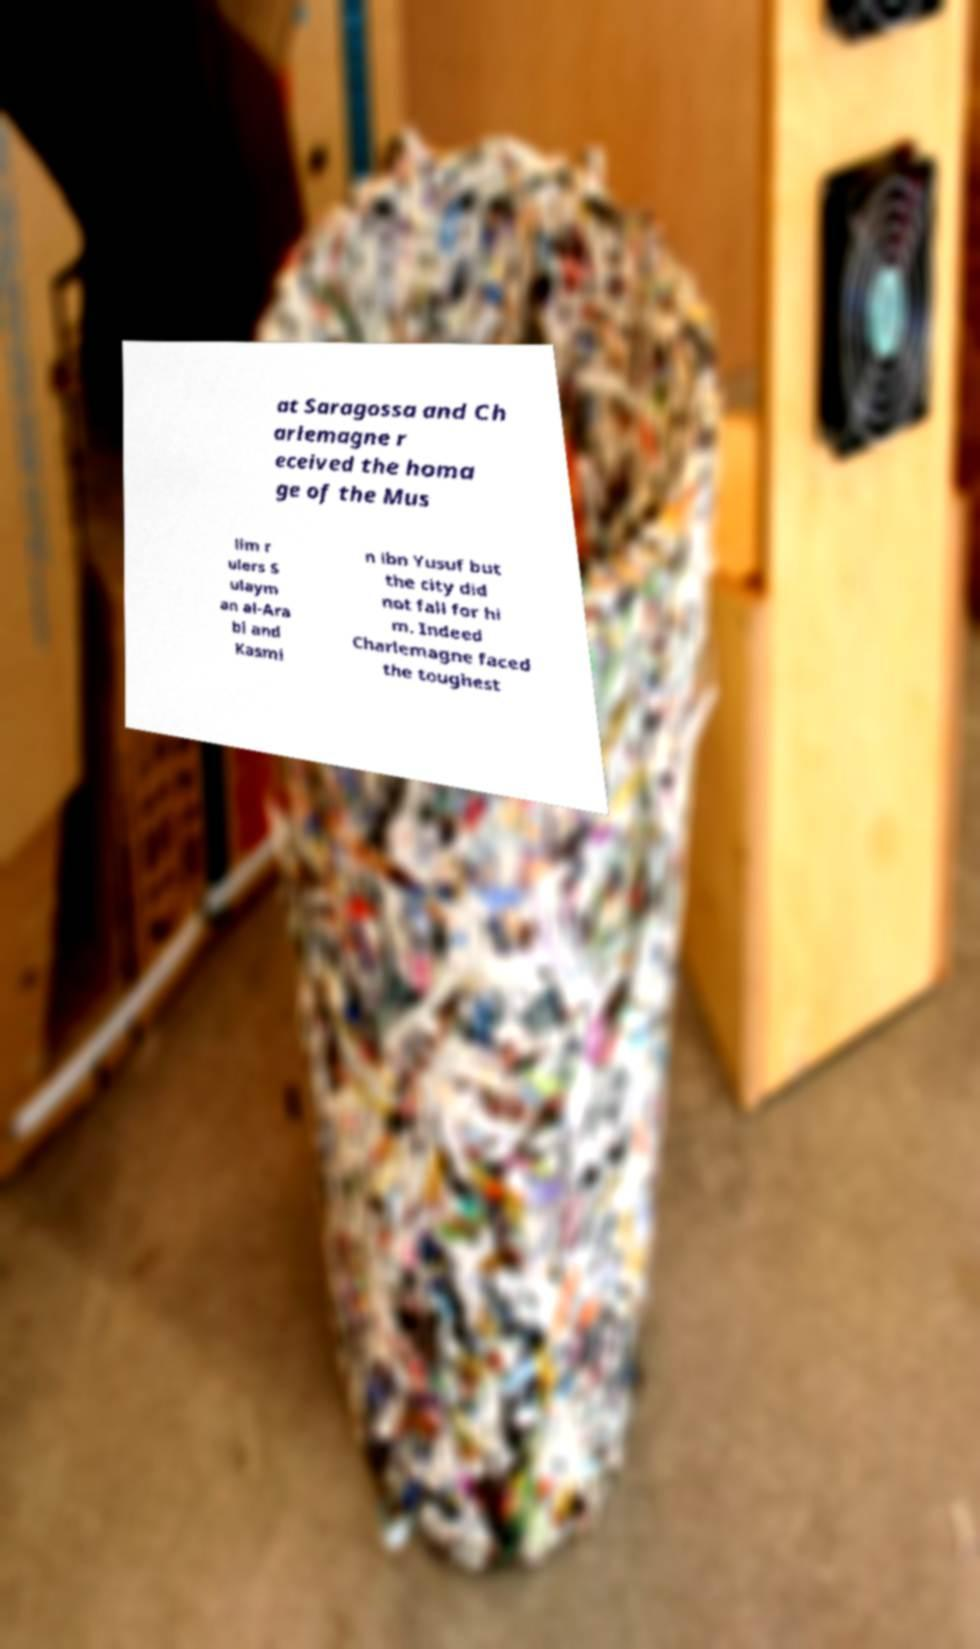There's text embedded in this image that I need extracted. Can you transcribe it verbatim? at Saragossa and Ch arlemagne r eceived the homa ge of the Mus lim r ulers S ulaym an al-Ara bi and Kasmi n ibn Yusuf but the city did not fall for hi m. Indeed Charlemagne faced the toughest 